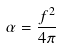<formula> <loc_0><loc_0><loc_500><loc_500>\alpha = \frac { f ^ { 2 } } { 4 \pi }</formula> 